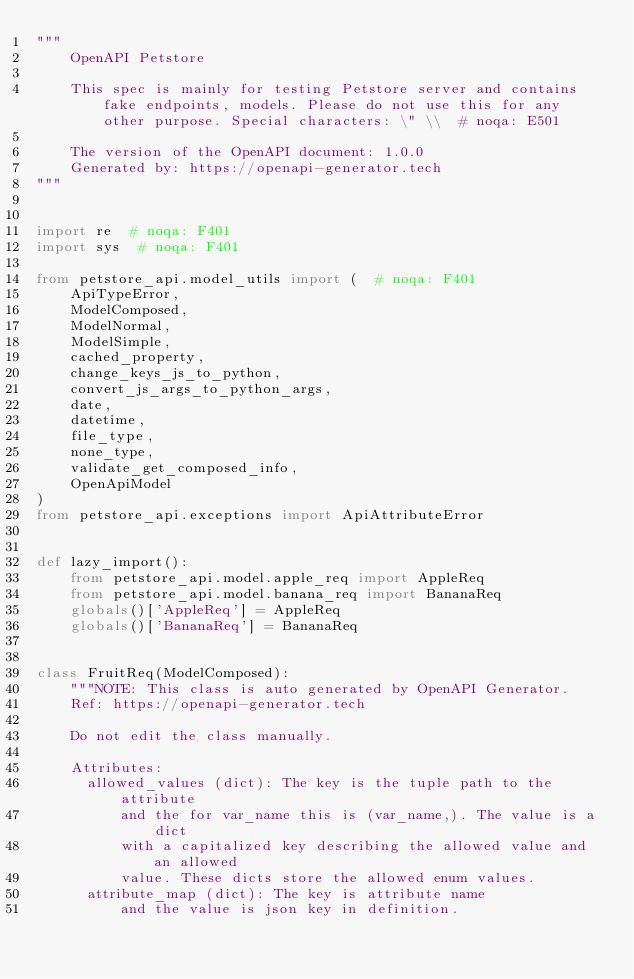Convert code to text. <code><loc_0><loc_0><loc_500><loc_500><_Python_>"""
    OpenAPI Petstore

    This spec is mainly for testing Petstore server and contains fake endpoints, models. Please do not use this for any other purpose. Special characters: \" \\  # noqa: E501

    The version of the OpenAPI document: 1.0.0
    Generated by: https://openapi-generator.tech
"""


import re  # noqa: F401
import sys  # noqa: F401

from petstore_api.model_utils import (  # noqa: F401
    ApiTypeError,
    ModelComposed,
    ModelNormal,
    ModelSimple,
    cached_property,
    change_keys_js_to_python,
    convert_js_args_to_python_args,
    date,
    datetime,
    file_type,
    none_type,
    validate_get_composed_info,
    OpenApiModel
)
from petstore_api.exceptions import ApiAttributeError


def lazy_import():
    from petstore_api.model.apple_req import AppleReq
    from petstore_api.model.banana_req import BananaReq
    globals()['AppleReq'] = AppleReq
    globals()['BananaReq'] = BananaReq


class FruitReq(ModelComposed):
    """NOTE: This class is auto generated by OpenAPI Generator.
    Ref: https://openapi-generator.tech

    Do not edit the class manually.

    Attributes:
      allowed_values (dict): The key is the tuple path to the attribute
          and the for var_name this is (var_name,). The value is a dict
          with a capitalized key describing the allowed value and an allowed
          value. These dicts store the allowed enum values.
      attribute_map (dict): The key is attribute name
          and the value is json key in definition.</code> 